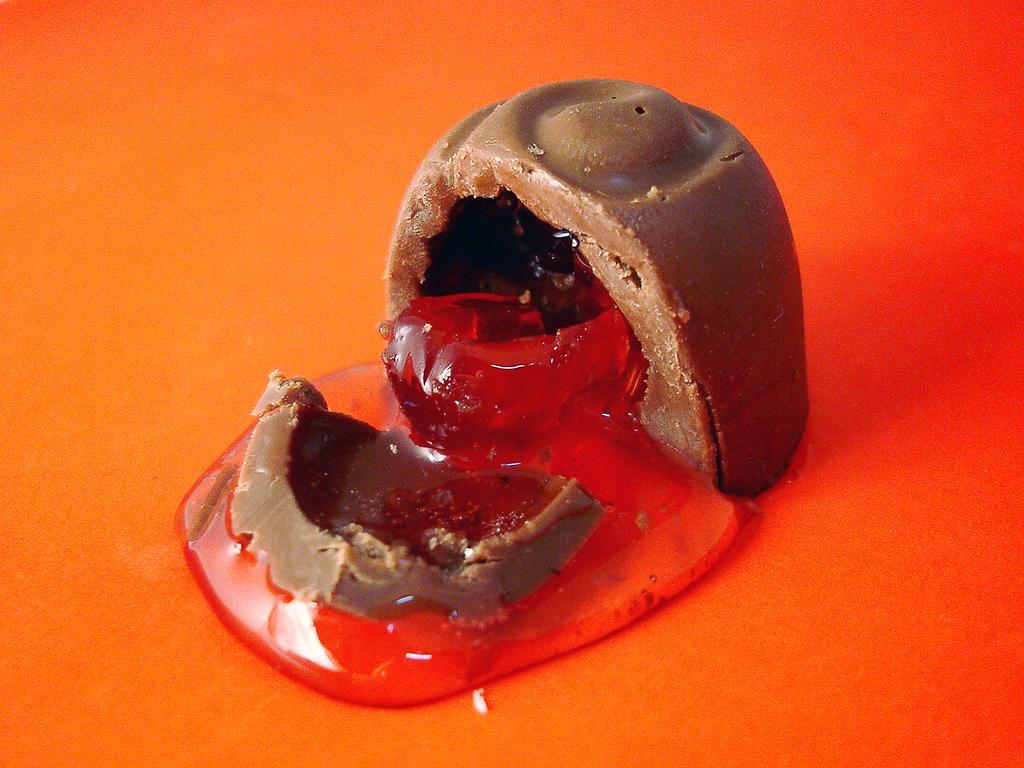What is the main subject in the center of the image? There is a chocolate in the center of the image. What is happening to the chocolate? There is a substance coming out of the chocolate. What color is present at the bottom of the image? There is an orange color at the bottom of the image. What type of pie is being served with a quill in the image? There is no pie or quill present in the image; it features a chocolate with a substance coming out of it and an orange color at the bottom. 